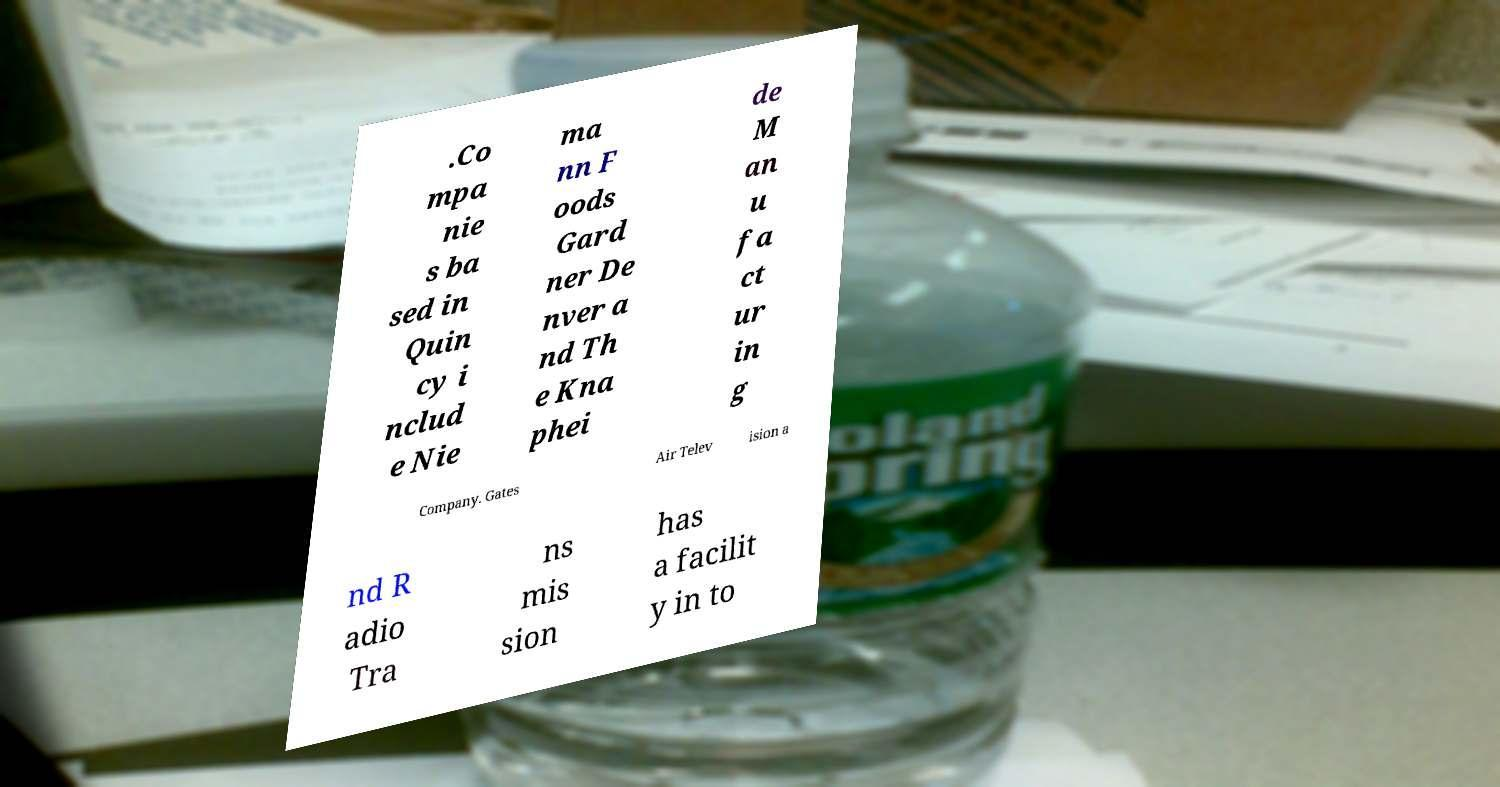Can you read and provide the text displayed in the image?This photo seems to have some interesting text. Can you extract and type it out for me? .Co mpa nie s ba sed in Quin cy i nclud e Nie ma nn F oods Gard ner De nver a nd Th e Kna phei de M an u fa ct ur in g Company. Gates Air Telev ision a nd R adio Tra ns mis sion has a facilit y in to 